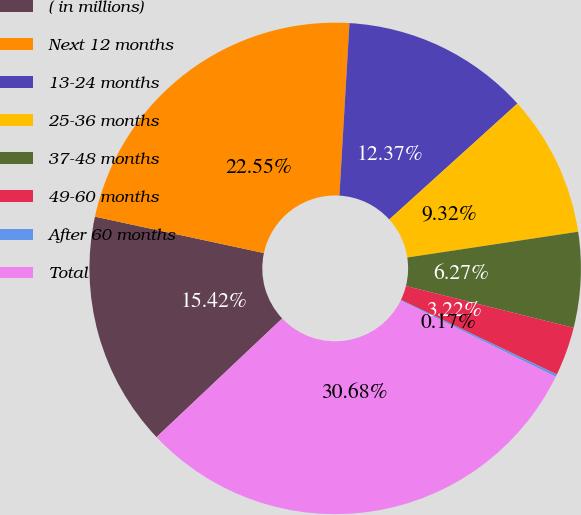Convert chart. <chart><loc_0><loc_0><loc_500><loc_500><pie_chart><fcel>( in millions)<fcel>Next 12 months<fcel>13-24 months<fcel>25-36 months<fcel>37-48 months<fcel>49-60 months<fcel>After 60 months<fcel>Total<nl><fcel>15.42%<fcel>22.55%<fcel>12.37%<fcel>9.32%<fcel>6.27%<fcel>3.22%<fcel>0.17%<fcel>30.68%<nl></chart> 